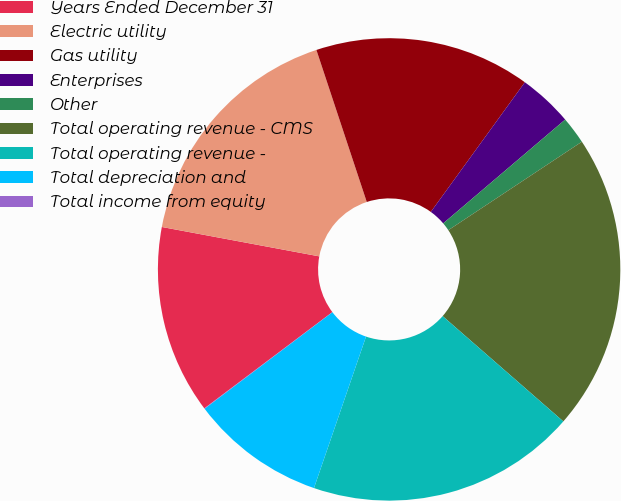Convert chart to OTSL. <chart><loc_0><loc_0><loc_500><loc_500><pie_chart><fcel>Years Ended December 31<fcel>Electric utility<fcel>Gas utility<fcel>Enterprises<fcel>Other<fcel>Total operating revenue - CMS<fcel>Total operating revenue -<fcel>Total depreciation and<fcel>Total income from equity<nl><fcel>13.2%<fcel>16.97%<fcel>15.08%<fcel>3.79%<fcel>1.91%<fcel>20.73%<fcel>18.85%<fcel>9.44%<fcel>0.03%<nl></chart> 